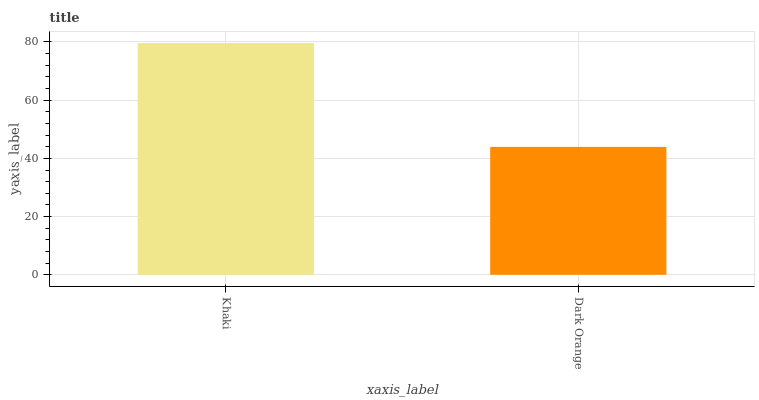Is Dark Orange the minimum?
Answer yes or no. Yes. Is Khaki the maximum?
Answer yes or no. Yes. Is Dark Orange the maximum?
Answer yes or no. No. Is Khaki greater than Dark Orange?
Answer yes or no. Yes. Is Dark Orange less than Khaki?
Answer yes or no. Yes. Is Dark Orange greater than Khaki?
Answer yes or no. No. Is Khaki less than Dark Orange?
Answer yes or no. No. Is Khaki the high median?
Answer yes or no. Yes. Is Dark Orange the low median?
Answer yes or no. Yes. Is Dark Orange the high median?
Answer yes or no. No. Is Khaki the low median?
Answer yes or no. No. 